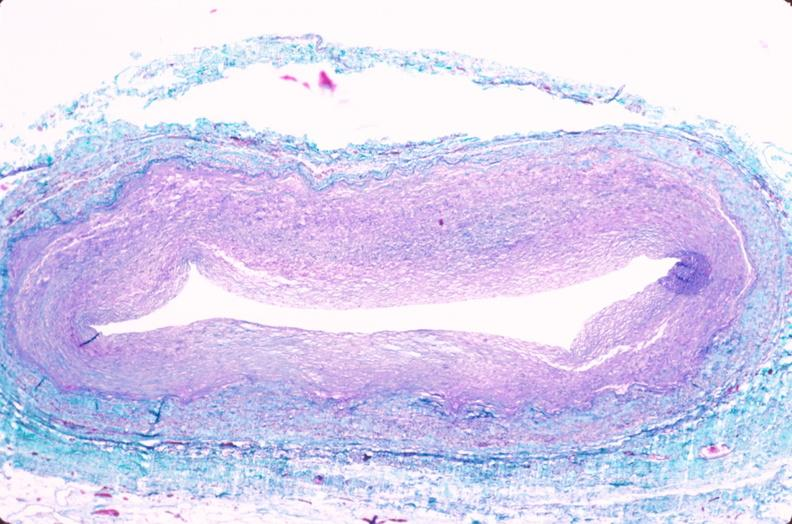what does this image show?
Answer the question using a single word or phrase. Saphenous vein graft sclerosis 